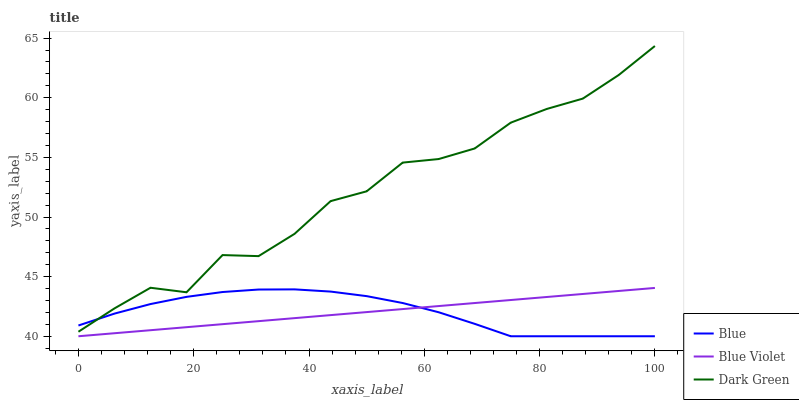Does Blue Violet have the minimum area under the curve?
Answer yes or no. Yes. Does Dark Green have the maximum area under the curve?
Answer yes or no. Yes. Does Dark Green have the minimum area under the curve?
Answer yes or no. No. Does Blue Violet have the maximum area under the curve?
Answer yes or no. No. Is Blue Violet the smoothest?
Answer yes or no. Yes. Is Dark Green the roughest?
Answer yes or no. Yes. Is Dark Green the smoothest?
Answer yes or no. No. Is Blue Violet the roughest?
Answer yes or no. No. Does Blue have the lowest value?
Answer yes or no. Yes. Does Dark Green have the lowest value?
Answer yes or no. No. Does Dark Green have the highest value?
Answer yes or no. Yes. Does Blue Violet have the highest value?
Answer yes or no. No. Is Blue Violet less than Dark Green?
Answer yes or no. Yes. Is Dark Green greater than Blue Violet?
Answer yes or no. Yes. Does Blue intersect Blue Violet?
Answer yes or no. Yes. Is Blue less than Blue Violet?
Answer yes or no. No. Is Blue greater than Blue Violet?
Answer yes or no. No. Does Blue Violet intersect Dark Green?
Answer yes or no. No. 